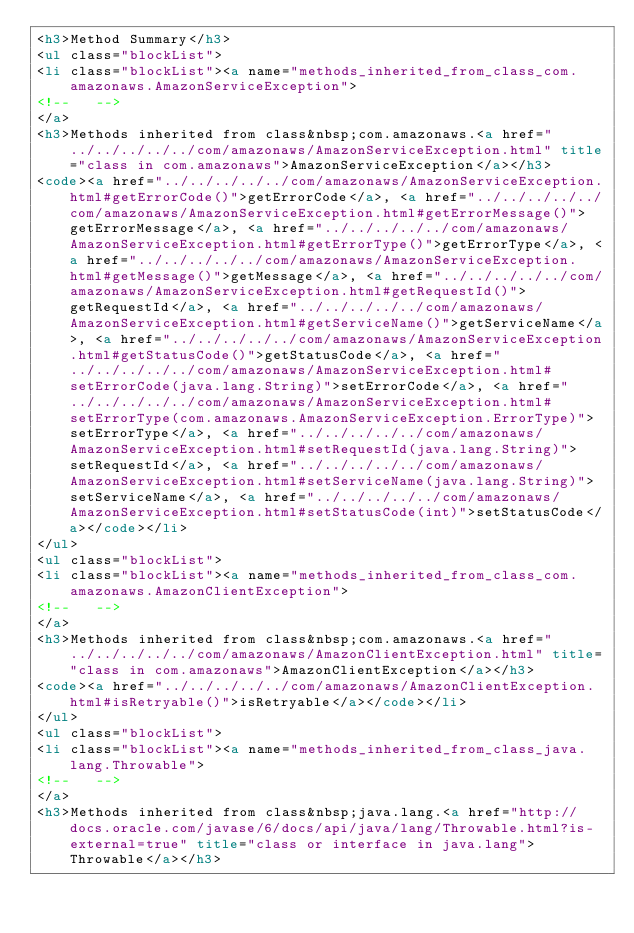Convert code to text. <code><loc_0><loc_0><loc_500><loc_500><_HTML_><h3>Method Summary</h3>
<ul class="blockList">
<li class="blockList"><a name="methods_inherited_from_class_com.amazonaws.AmazonServiceException">
<!--   -->
</a>
<h3>Methods inherited from class&nbsp;com.amazonaws.<a href="../../../../../com/amazonaws/AmazonServiceException.html" title="class in com.amazonaws">AmazonServiceException</a></h3>
<code><a href="../../../../../com/amazonaws/AmazonServiceException.html#getErrorCode()">getErrorCode</a>, <a href="../../../../../com/amazonaws/AmazonServiceException.html#getErrorMessage()">getErrorMessage</a>, <a href="../../../../../com/amazonaws/AmazonServiceException.html#getErrorType()">getErrorType</a>, <a href="../../../../../com/amazonaws/AmazonServiceException.html#getMessage()">getMessage</a>, <a href="../../../../../com/amazonaws/AmazonServiceException.html#getRequestId()">getRequestId</a>, <a href="../../../../../com/amazonaws/AmazonServiceException.html#getServiceName()">getServiceName</a>, <a href="../../../../../com/amazonaws/AmazonServiceException.html#getStatusCode()">getStatusCode</a>, <a href="../../../../../com/amazonaws/AmazonServiceException.html#setErrorCode(java.lang.String)">setErrorCode</a>, <a href="../../../../../com/amazonaws/AmazonServiceException.html#setErrorType(com.amazonaws.AmazonServiceException.ErrorType)">setErrorType</a>, <a href="../../../../../com/amazonaws/AmazonServiceException.html#setRequestId(java.lang.String)">setRequestId</a>, <a href="../../../../../com/amazonaws/AmazonServiceException.html#setServiceName(java.lang.String)">setServiceName</a>, <a href="../../../../../com/amazonaws/AmazonServiceException.html#setStatusCode(int)">setStatusCode</a></code></li>
</ul>
<ul class="blockList">
<li class="blockList"><a name="methods_inherited_from_class_com.amazonaws.AmazonClientException">
<!--   -->
</a>
<h3>Methods inherited from class&nbsp;com.amazonaws.<a href="../../../../../com/amazonaws/AmazonClientException.html" title="class in com.amazonaws">AmazonClientException</a></h3>
<code><a href="../../../../../com/amazonaws/AmazonClientException.html#isRetryable()">isRetryable</a></code></li>
</ul>
<ul class="blockList">
<li class="blockList"><a name="methods_inherited_from_class_java.lang.Throwable">
<!--   -->
</a>
<h3>Methods inherited from class&nbsp;java.lang.<a href="http://docs.oracle.com/javase/6/docs/api/java/lang/Throwable.html?is-external=true" title="class or interface in java.lang">Throwable</a></h3></code> 